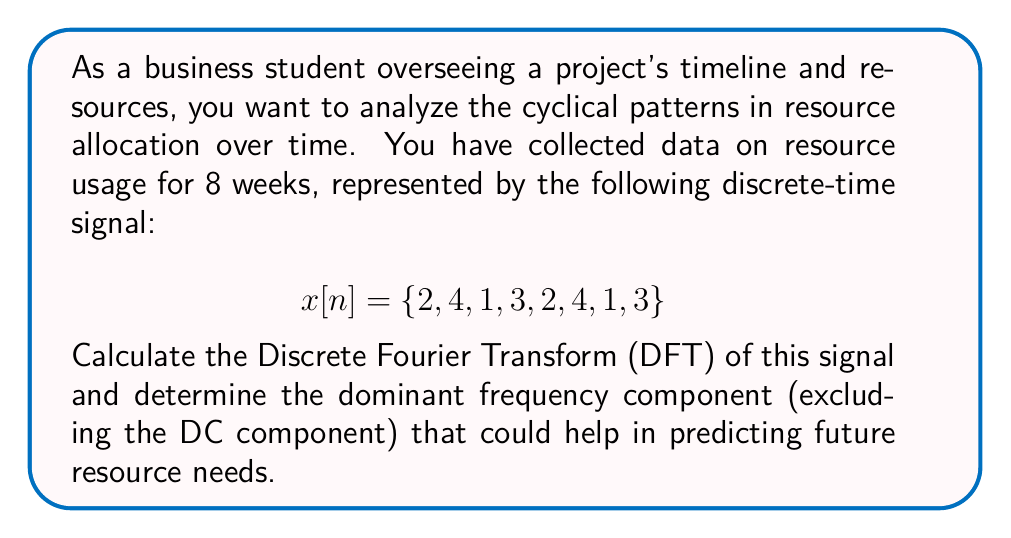Solve this math problem. To solve this problem, we'll follow these steps:

1) Calculate the DFT of the given signal.
2) Analyze the magnitude spectrum to find the dominant frequency.

Step 1: Calculating the DFT

The DFT is given by the formula:

$$X[k] = \sum_{n=0}^{N-1} x[n] e^{-j2\pi kn/N}$$

Where $N = 8$ (the number of samples), $k = 0, 1, ..., 7$, and $j$ is the imaginary unit.

Let's calculate $X[k]$ for each $k$:

$X[0] = 2 + 4 + 1 + 3 + 2 + 4 + 1 + 3 = 20$ (DC component)

$X[1] = 2 + 4e^{-j\pi/4} + 1e^{-j\pi/2} + 3e^{-j3\pi/4} + 2e^{-j\pi} + 4e^{-j5\pi/4} + 1e^{-j3\pi/2} + 3e^{-j7\pi/4} = 4 - 4j$

$X[2] = 2 + 4e^{-j\pi/2} + 1e^{-j\pi} + 3e^{-j3\pi/2} + 2e^{-j2\pi} + 4e^{-j5\pi/2} + 1e^{-j3\pi} + 3e^{-j7\pi/2} = -4$

$X[3] = 2 + 4e^{-j3\pi/4} + 1e^{-j3\pi/2} + 3e^{-j9\pi/4} + 2e^{-j3\pi} + 4e^{-j15\pi/4} + 1e^{-j9\pi/2} + 3e^{-j21\pi/4} = 0 + 4j$

$X[4] = 2 + 4e^{-j\pi} + 1e^{-j2\pi} + 3e^{-j3\pi} + 2e^{-j4\pi} + 4e^{-j5\pi} + 1e^{-j6\pi} + 3e^{-j7\pi} = 4$

$X[5], X[6], X[7]$ are complex conjugates of $X[3], X[2], X[1]$ respectively.

Step 2: Analyzing the magnitude spectrum

To find the dominant frequency, we need to look at the magnitude of each component:

$|X[0]| = 20$ (DC component, ignored for this analysis)
$|X[1]| = |X[7]| = \sqrt{4^2 + 4^2} = 4\sqrt{2} \approx 5.66$
$|X[2]| = |X[6]| = 4$
$|X[3]| = |X[5]| = 4$
$|X[4]| = 4$

The largest magnitude (excluding DC) is at $k=1$ and $k=7$, which correspond to the same frequency due to the periodicity of DFT.
Answer: The dominant frequency component is at $k=1$ (and its symmetric counterpart at $k=7$) with a magnitude of $4\sqrt{2} \approx 5.66$. This suggests a strong cyclic pattern that repeats every 8 weeks, which could be used to predict future resource needs and optimize allocation. 